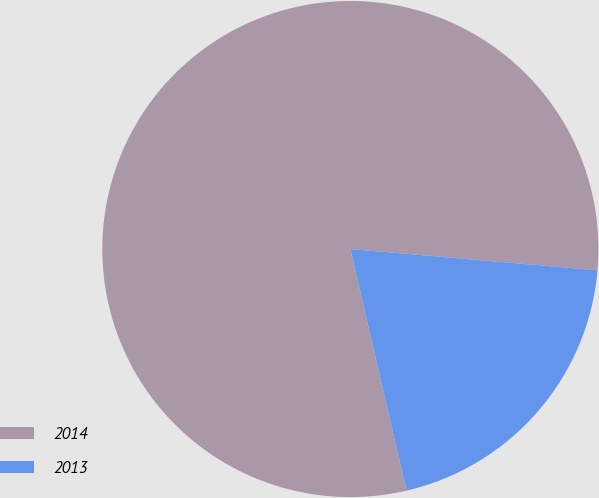<chart> <loc_0><loc_0><loc_500><loc_500><pie_chart><fcel>2014<fcel>2013<nl><fcel>80.0%<fcel>20.0%<nl></chart> 